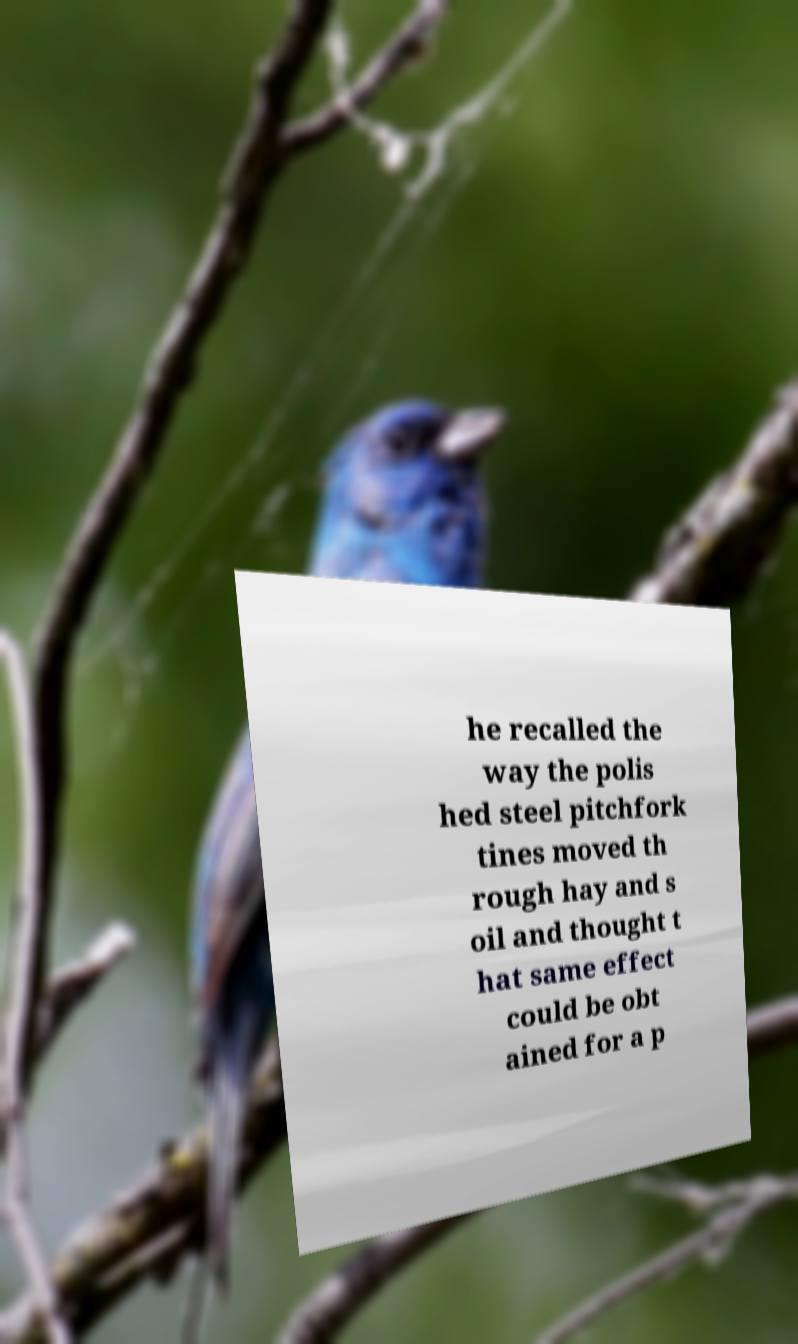Can you accurately transcribe the text from the provided image for me? he recalled the way the polis hed steel pitchfork tines moved th rough hay and s oil and thought t hat same effect could be obt ained for a p 